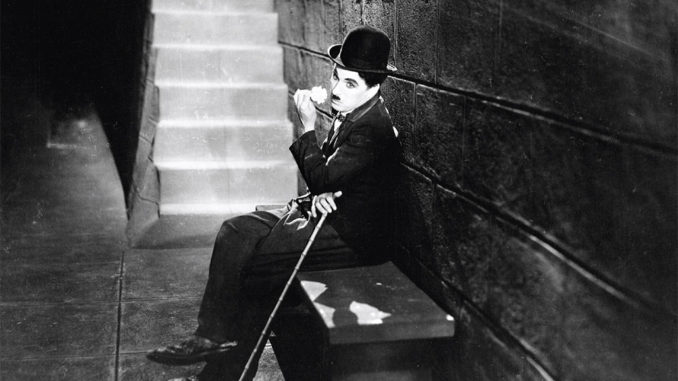Describe the scene from the image as it might be used in a silent film script. INT. CITY BACK ALLEY - DAY

The stone walls of the alley close in around CHARLIE CHAPLIN's beloved character, THE TRAMP, who sits on a small stone bench. His ever-present CANE rests delicately across his lap, and his BOWLER HAT is tilted just so atop his head. The TRAMP's eyes are cast thoughtfully to the side, as if he's lost in a memory or deep in thought. The steps of a STAIRCASE leading out of this confined space suggest the promise of an escape or the end of a journey, but for now, the TRAMP remains in quiet contemplation. The monochromatic palette of the scene speaks volumes, echoing the silent struggles and gentle humor that have become the TRAMP's signature. Without a single word, the image conveys a poignant moment of reflection and the whimsical resilience of a beloved cinematic hero. 